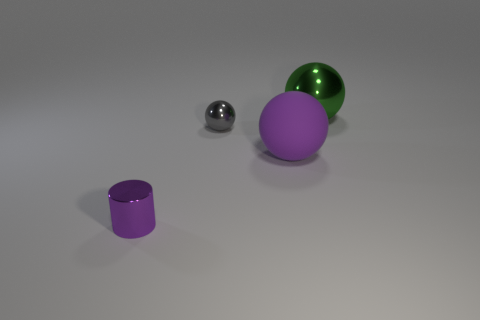Is there any other thing that is the same material as the large purple thing?
Give a very brief answer. No. Is the gray object made of the same material as the purple sphere?
Your answer should be very brief. No. How many objects are purple things left of the big purple rubber thing or tiny green things?
Your answer should be very brief. 1. Are there the same number of big green metallic things that are on the right side of the large green metal thing and tiny metallic objects behind the tiny purple metallic cylinder?
Keep it short and to the point. No. What is the color of the other big metallic object that is the same shape as the large purple thing?
Provide a short and direct response. Green. Is there any other thing that is the same shape as the small purple thing?
Offer a very short reply. No. There is a small cylinder that is in front of the big green thing; is it the same color as the big matte object?
Offer a very short reply. Yes. What is the size of the purple rubber thing that is the same shape as the large shiny thing?
Keep it short and to the point. Large. How many small purple cylinders are the same material as the tiny sphere?
Offer a terse response. 1. There is a large ball that is in front of the shiny ball behind the small gray metallic ball; are there any big spheres that are behind it?
Provide a short and direct response. Yes. 